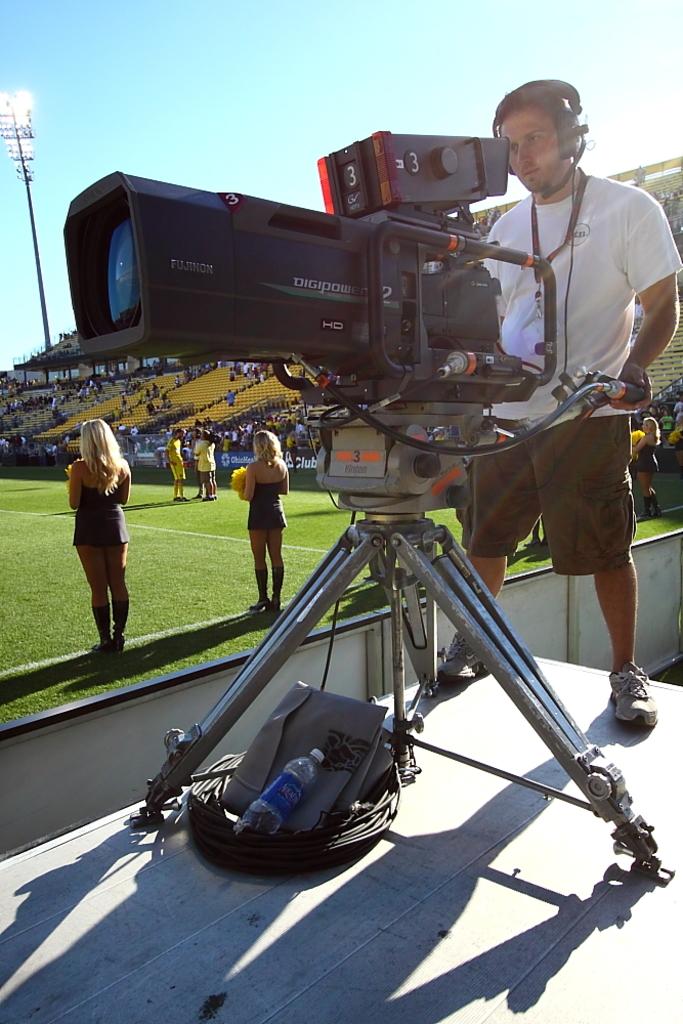Is he working camera 3?
Provide a succinct answer. Yes. 